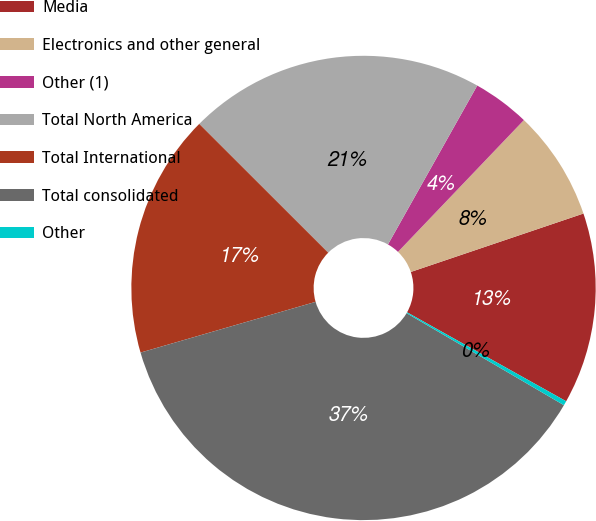Convert chart to OTSL. <chart><loc_0><loc_0><loc_500><loc_500><pie_chart><fcel>Media<fcel>Electronics and other general<fcel>Other (1)<fcel>Total North America<fcel>Total International<fcel>Total consolidated<fcel>Other<nl><fcel>13.31%<fcel>7.67%<fcel>3.99%<fcel>20.66%<fcel>16.98%<fcel>37.09%<fcel>0.31%<nl></chart> 